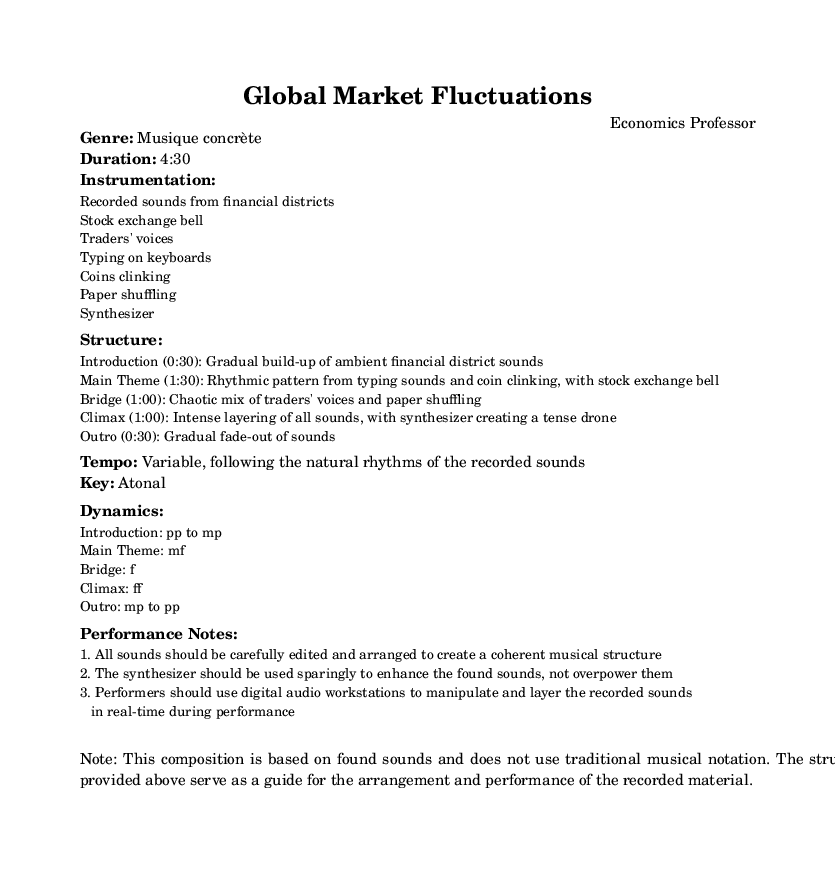What is the genre of this composition? The genre is explicitly stated in the sheet music under the "Genre" section as "Musique concrète."
Answer: Musique concrète What is the duration of the piece? The duration is listed in the "Duration" section of the markup as "4:30."
Answer: 4:30 What kind of sounds are used for the composition? The sounds used are detailed in the "Instrumentation" section, which lists "Recorded sounds from financial districts," "Stock exchange bell," "Traders' voices," etc.
Answer: Recorded sounds from financial districts, Stock exchange bell, Traders' voices, Typing on keyboards, Coins clinking, Paper shuffling, Synthesizer What is the dynamic marking for the Climax section? The "Climax" section specifies the dynamic as "ff" (fortissimo), indicating a very loud volume.
Answer: ff Why is the tempo described as variable? The tempo is stated to be "Variable, following the natural rhythms of the recorded sounds" in the tempo section, indicating that it is contingent on the found sounds.
Answer: Variable, following the natural rhythms of the recorded sounds What performance technique is suggested for manipulating sounds? The performance notes mention using "digital audio workstations to manipulate and layer the recorded sounds in real-time during performance," which suggests a specific technique for sound manipulation.
Answer: Digital audio workstations What does the structure of the piece imply about the overall design? The structure outlines different sections with varying characteristics such as the "Gradual build-up," "Chaotic mix," and "Intense layering," indicating a complex arrangement that reflects economic fluctuations.
Answer: Complex arrangement 